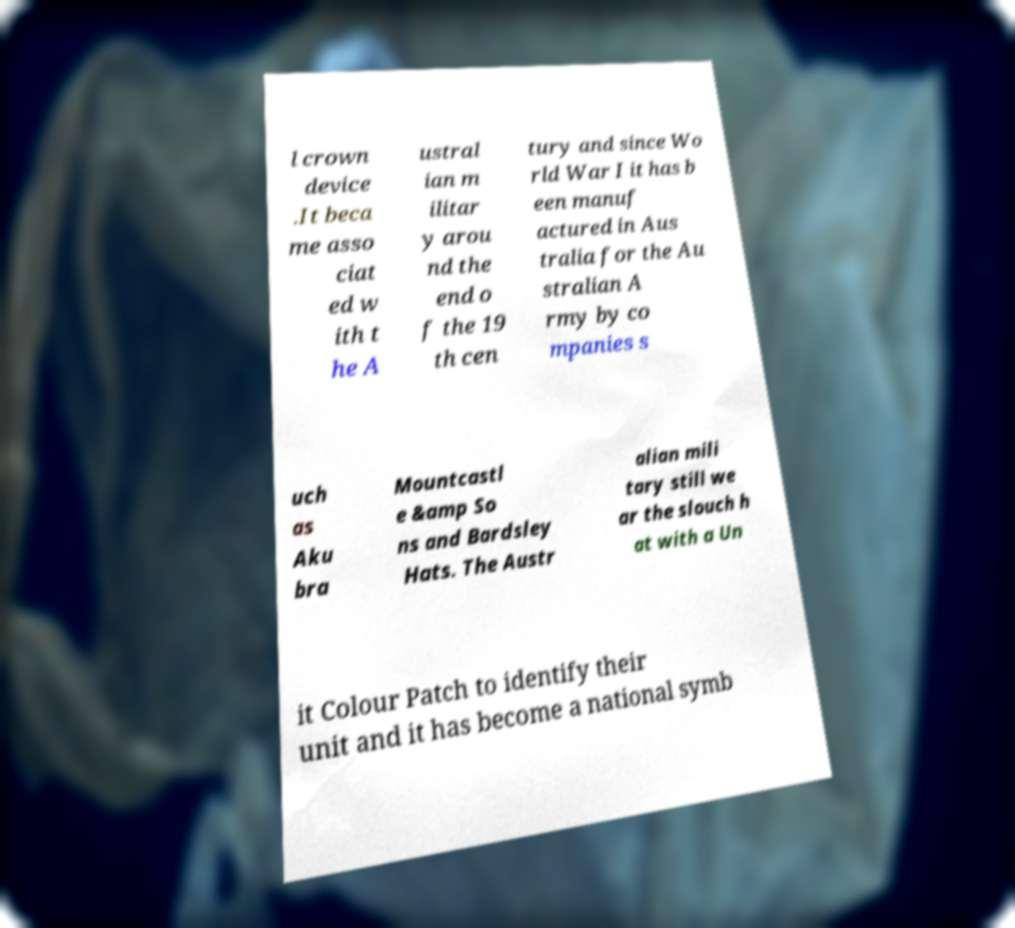Can you accurately transcribe the text from the provided image for me? l crown device .It beca me asso ciat ed w ith t he A ustral ian m ilitar y arou nd the end o f the 19 th cen tury and since Wo rld War I it has b een manuf actured in Aus tralia for the Au stralian A rmy by co mpanies s uch as Aku bra Mountcastl e &amp So ns and Bardsley Hats. The Austr alian mili tary still we ar the slouch h at with a Un it Colour Patch to identify their unit and it has become a national symb 